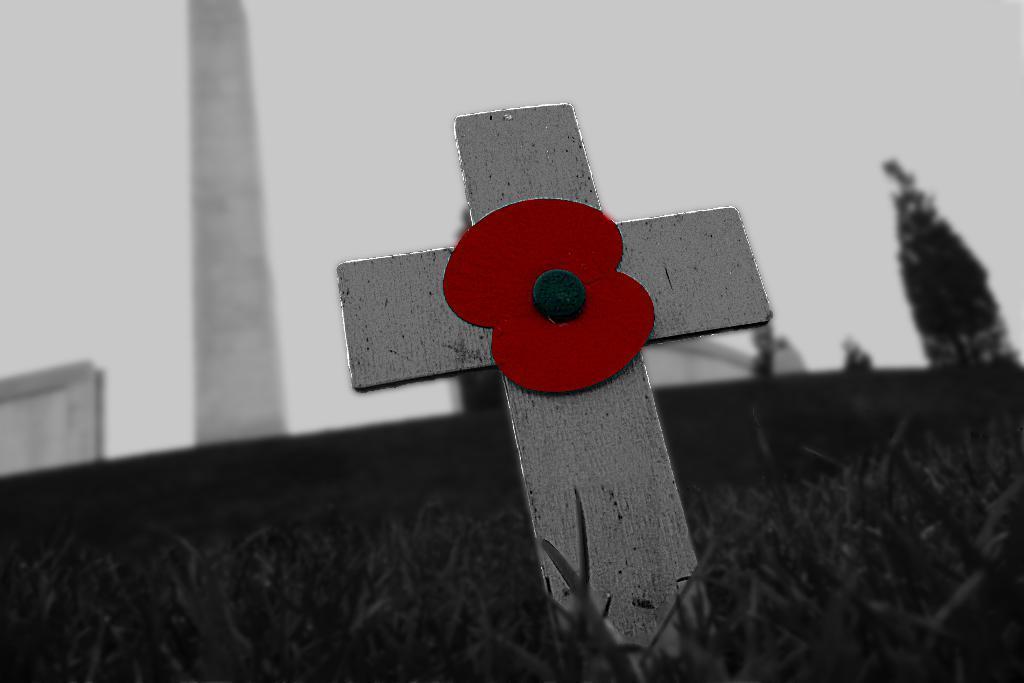How would you summarize this image in a sentence or two? In this image I can see the grass and a pole which is black, red and ash in color in the grass. In the background I can see a tree, few other objects and the sky. 